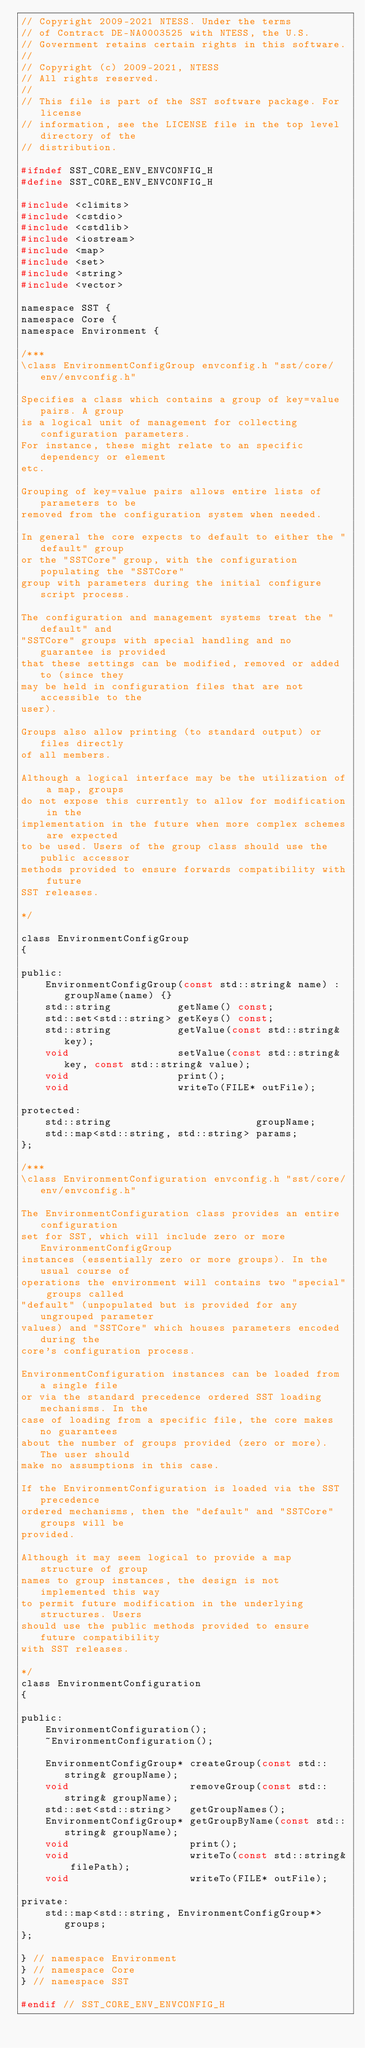Convert code to text. <code><loc_0><loc_0><loc_500><loc_500><_C_>// Copyright 2009-2021 NTESS. Under the terms
// of Contract DE-NA0003525 with NTESS, the U.S.
// Government retains certain rights in this software.
//
// Copyright (c) 2009-2021, NTESS
// All rights reserved.
//
// This file is part of the SST software package. For license
// information, see the LICENSE file in the top level directory of the
// distribution.

#ifndef SST_CORE_ENV_ENVCONFIG_H
#define SST_CORE_ENV_ENVCONFIG_H

#include <climits>
#include <cstdio>
#include <cstdlib>
#include <iostream>
#include <map>
#include <set>
#include <string>
#include <vector>

namespace SST {
namespace Core {
namespace Environment {

/***
\class EnvironmentConfigGroup envconfig.h "sst/core/env/envconfig.h"

Specifies a class which contains a group of key=value pairs. A group
is a logical unit of management for collecting configuration parameters.
For instance, these might relate to an specific dependency or element
etc.

Grouping of key=value pairs allows entire lists of parameters to be
removed from the configuration system when needed.

In general the core expects to default to either the "default" group
or the "SSTCore" group, with the configuration populating the "SSTCore"
group with parameters during the initial configure script process.

The configuration and management systems treat the "default" and
"SSTCore" groups with special handling and no guarantee is provided
that these settings can be modified, removed or added to (since they
may be held in configuration files that are not accessible to the
user).

Groups also allow printing (to standard output) or files directly
of all members.

Although a logical interface may be the utilization of a map, groups
do not expose this currently to allow for modification in the
implementation in the future when more complex schemes are expected
to be used. Users of the group class should use the public accessor
methods provided to ensure forwards compatibility with future
SST releases.

*/

class EnvironmentConfigGroup
{

public:
    EnvironmentConfigGroup(const std::string& name) : groupName(name) {}
    std::string           getName() const;
    std::set<std::string> getKeys() const;
    std::string           getValue(const std::string& key);
    void                  setValue(const std::string& key, const std::string& value);
    void                  print();
    void                  writeTo(FILE* outFile);

protected:
    std::string                        groupName;
    std::map<std::string, std::string> params;
};

/***
\class EnvironmentConfiguration envconfig.h "sst/core/env/envconfig.h"

The EnvironmentConfiguration class provides an entire configuration
set for SST, which will include zero or more EnvironmentConfigGroup
instances (essentially zero or more groups). In the usual course of
operations the environment will contains two "special" groups called
"default" (unpopulated but is provided for any ungrouped parameter
values) and "SSTCore" which houses parameters encoded during the
core's configuration process.

EnvironmentConfiguration instances can be loaded from a single file
or via the standard precedence ordered SST loading mechanisms. In the
case of loading from a specific file, the core makes no guarantees
about the number of groups provided (zero or more). The user should
make no assumptions in this case.

If the EnvironmentConfiguration is loaded via the SST precedence
ordered mechanisms, then the "default" and "SSTCore" groups will be
provided.

Although it may seem logical to provide a map structure of group
names to group instances, the design is not implemented this way
to permit future modification in the underlying structures. Users
should use the public methods provided to ensure future compatibility
with SST releases.

*/
class EnvironmentConfiguration
{

public:
    EnvironmentConfiguration();
    ~EnvironmentConfiguration();

    EnvironmentConfigGroup* createGroup(const std::string& groupName);
    void                    removeGroup(const std::string& groupName);
    std::set<std::string>   getGroupNames();
    EnvironmentConfigGroup* getGroupByName(const std::string& groupName);
    void                    print();
    void                    writeTo(const std::string& filePath);
    void                    writeTo(FILE* outFile);

private:
    std::map<std::string, EnvironmentConfigGroup*> groups;
};

} // namespace Environment
} // namespace Core
} // namespace SST

#endif // SST_CORE_ENV_ENVCONFIG_H
</code> 